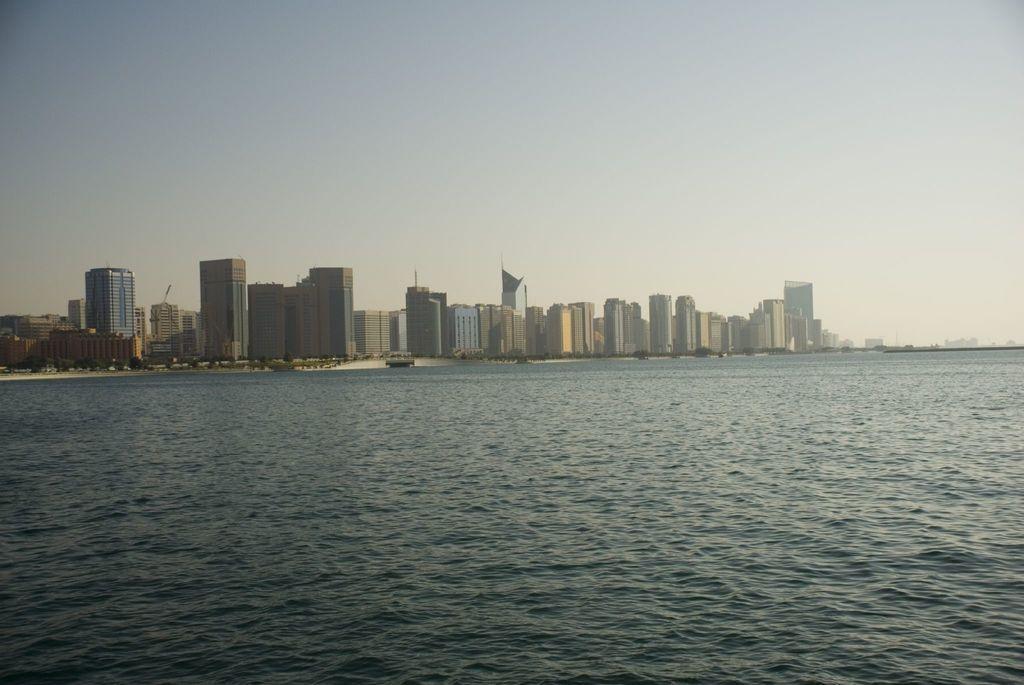In one or two sentences, can you explain what this image depicts? In this image I can see the water, few trees and few buildings. In the background I can see the sky. 